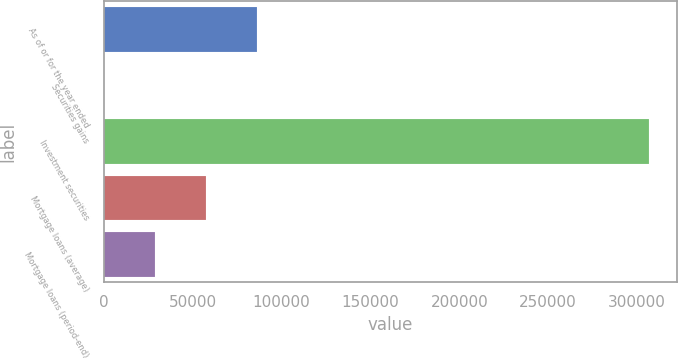Convert chart to OTSL. <chart><loc_0><loc_0><loc_500><loc_500><bar_chart><fcel>As of or for the year ended<fcel>Securities gains<fcel>Investment securities<fcel>Mortgage loans (average)<fcel>Mortgage loans (period-end)<nl><fcel>86143.8<fcel>132<fcel>306921<fcel>57473.2<fcel>28802.6<nl></chart> 